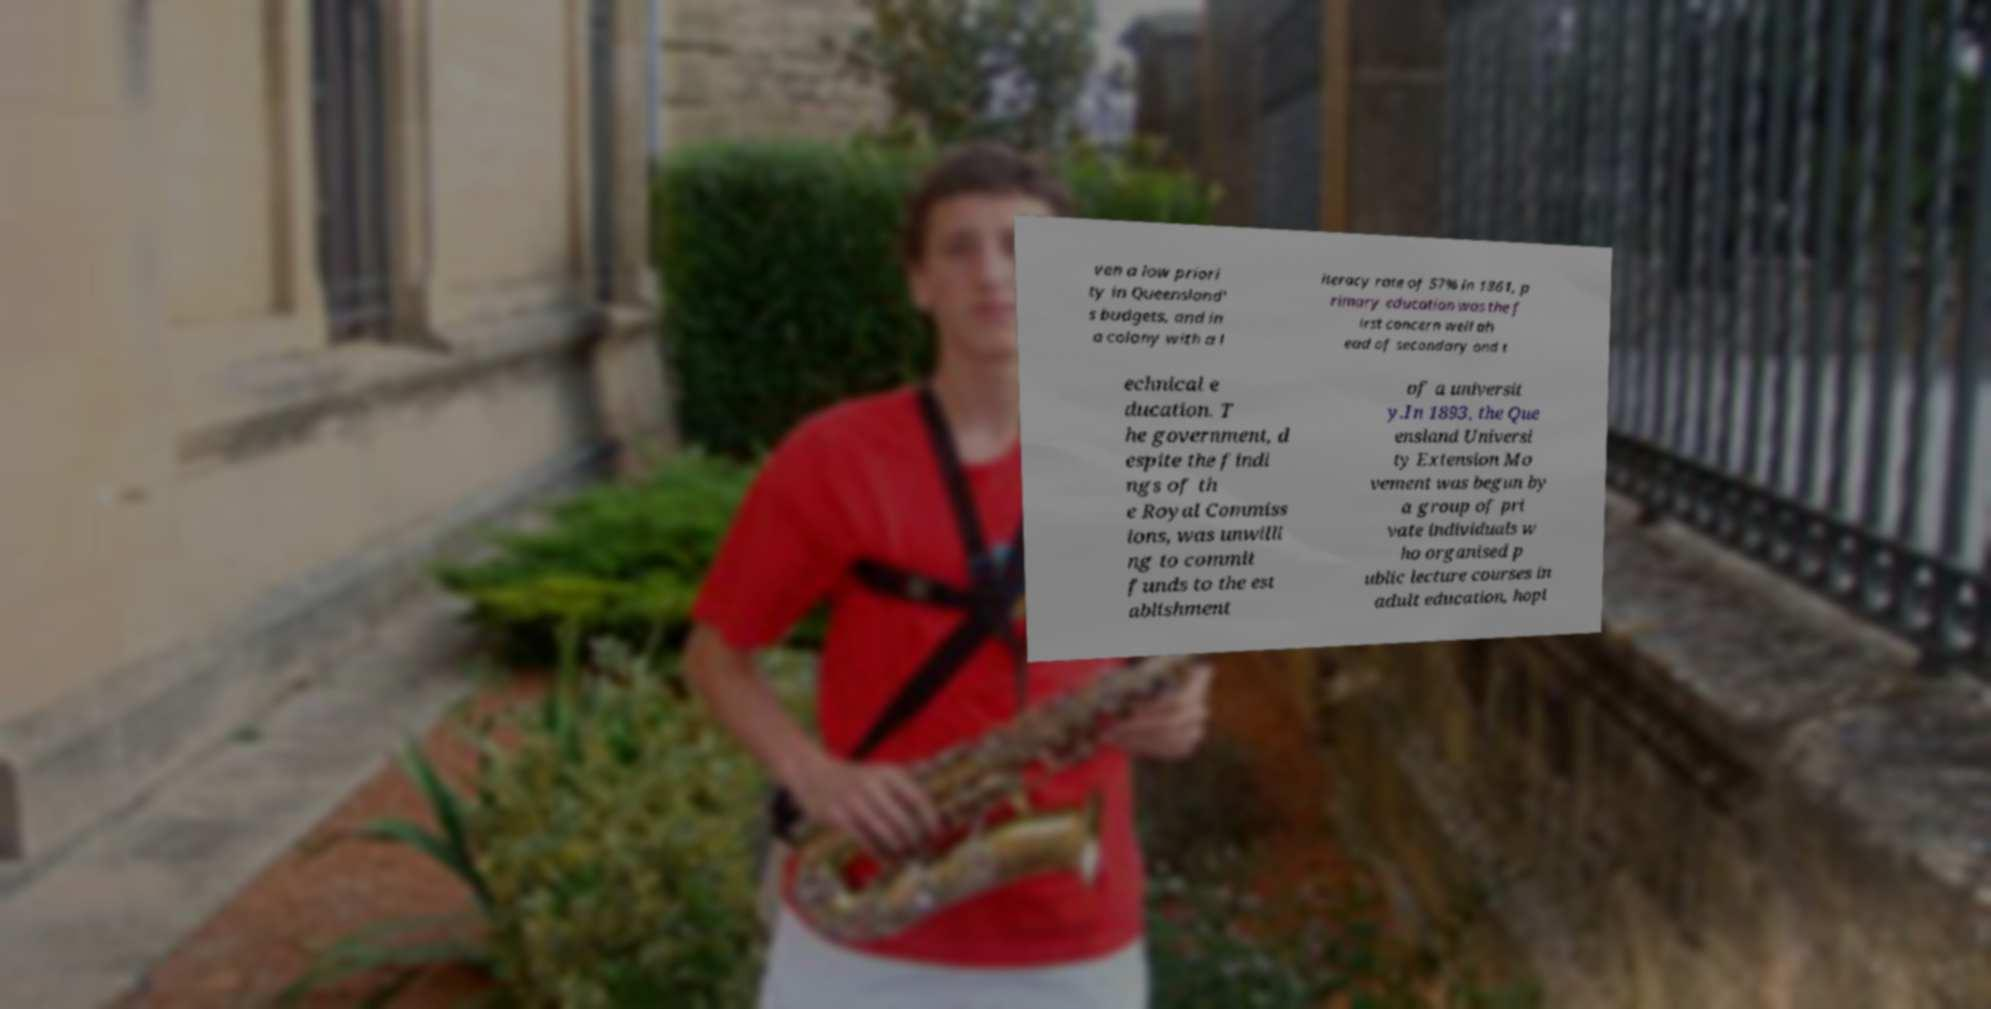Could you extract and type out the text from this image? ven a low priori ty in Queensland' s budgets, and in a colony with a l iteracy rate of 57% in 1861, p rimary education was the f irst concern well ah ead of secondary and t echnical e ducation. T he government, d espite the findi ngs of th e Royal Commiss ions, was unwilli ng to commit funds to the est ablishment of a universit y.In 1893, the Que ensland Universi ty Extension Mo vement was begun by a group of pri vate individuals w ho organised p ublic lecture courses in adult education, hopi 